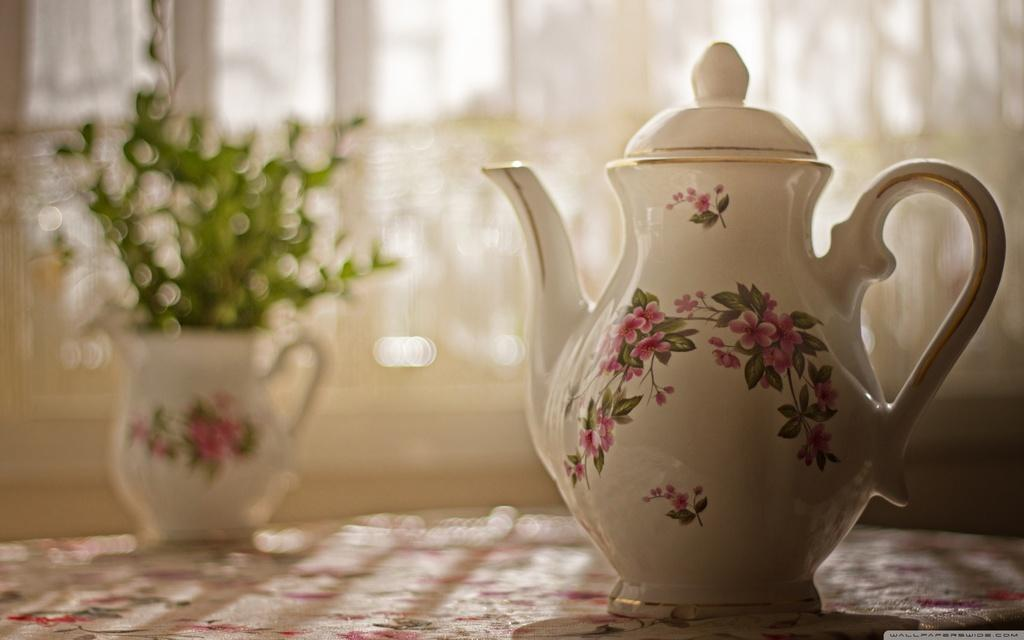What type of plant is in the image? There is a house plant in the image. What other object can be seen in the image? There is a kettle in the image. Can you describe the background of the image? The background of the image is blurry. What type of health issues does the house plant have in the image? There is no indication of any health issues with the house plant in the image. 